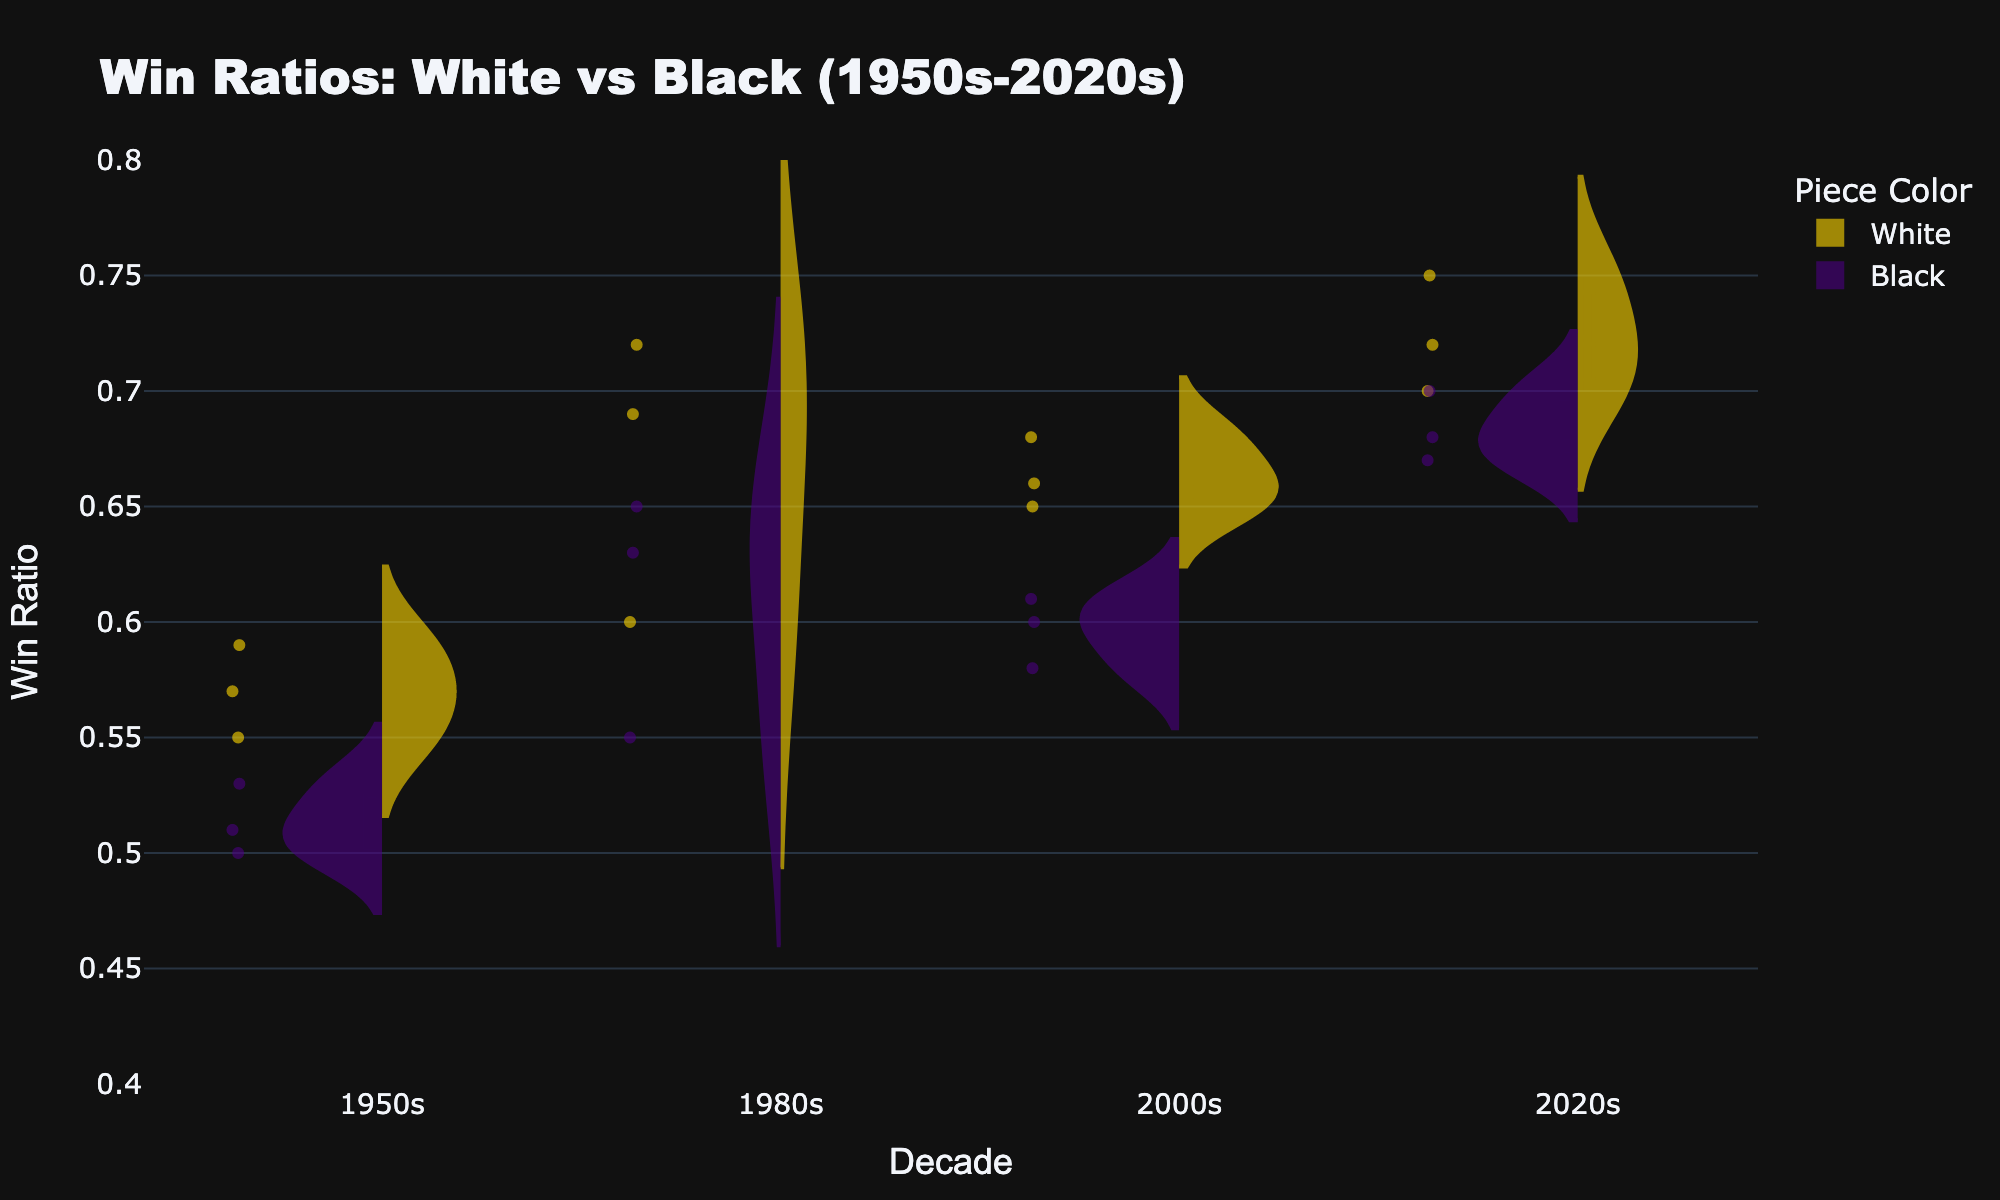how does the win ratio of black pieces compare across different decades? The violin plot shows the distribution of win ratios for black pieces in each decade. Observing each trace, the win ratios for black pieces from the 1950s to the 2020s show an increasing trend. The meanline in each violin plot provides a visual cue: starting around 0.51-0.53 in the 1950s, increasing to around 0.55-0.65 in the following decades, and peaking around 0.68-0.70 in the 2020s.
Answer: Increasing trend from the 1950s to 2020s Which decade shows the highest average win ratio for white pieces? To determine the highest average win ratio for white pieces, we look at the meanline in each violin plot for white pieces. The 2020s shows the highest meanline, indicating the highest average win ratio.
Answer: 2020s Are the distributions of win ratios for white pieces wider than those for black pieces in any decade? By comparing the spread of the violin plots for white pieces and black pieces in each decade, it appears that the distribution of win ratios for white pieces is consistently wider than for black pieces across all decades, indicating greater variability.
Answer: Yes, in all decades What is the median win ratio for white pieces in the 2000s? The median win ratio is indicated by the central line in the box plot overlay within the violin plot. For white pieces in the 2000s, the median falls around 0.66.
Answer: Around 0.66 Which set of players had a more consistent performance, those playing black or white pieces? Consistency can be measured by the spread of the values in the violin plots and the width of the boxes in the box plots. White pieces show a wider distribution and larger box sizes, suggesting greater variability. Conversely, the black pieces have tighter distributions and smaller boxes, indicating more consistent performance.
Answer: Black pieces Which decade displayed the smallest range in win ratios for black pieces? The range in win ratios can be judged by the spread of the violin plot and the length of the box plot for black pieces in each decade. The 1950s show the shortest range, indicating the smallest spread in win ratios.
Answer: 1950s Was there any decade where the mean win ratio of black pieces exceeded 0.6? Checking the meanline of the violin plots for black pieces in each decade, it is evident that in the 1980s, 2000s, and 2020s the mean win ratio for black pieces exceeded 0.6.
Answer: Yes, 1980s, 2000s, 2020s How did the variability of win ratios for white pieces change from the 1950s to the 2020s? Variability can be seen by the spread of the violin plot and the size of the box plot. From the 1950s to the 2020s, the variability increased significantly; the violin plots and corresponding box plots widened, indicating more varied performance in the more recent decades.
Answer: Increased In which decade was the interquartile range (IQR) of win ratios for white pieces the widest? The IQR is represented by the size of the box in the box plot overlay. Observing the box plots for white pieces, the 2020s have the widest box, indicating the greatest IQR.
Answer: 2020s 